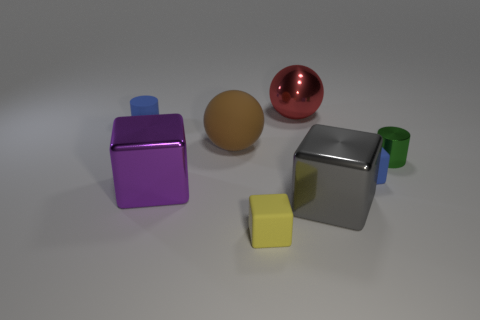There is a yellow thing; how many big metal balls are in front of it?
Make the answer very short. 0. What shape is the blue matte thing on the left side of the small cube that is to the right of the tiny yellow rubber thing?
Offer a very short reply. Cylinder. The gray thing that is made of the same material as the green cylinder is what shape?
Your response must be concise. Cube. There is a sphere to the left of the tiny yellow matte block; is it the same size as the shiny object that is behind the tiny green shiny cylinder?
Your response must be concise. Yes. The blue thing behind the brown matte sphere has what shape?
Your response must be concise. Cylinder. What color is the matte cylinder?
Provide a succinct answer. Blue. Do the brown matte ball and the shiny object behind the shiny cylinder have the same size?
Provide a succinct answer. Yes. What number of metal objects are either green blocks or large spheres?
Provide a short and direct response. 1. Is there any other thing that has the same material as the small green thing?
Your answer should be compact. Yes. There is a rubber cylinder; is it the same color as the small rubber cube that is to the right of the small yellow thing?
Offer a very short reply. Yes. 